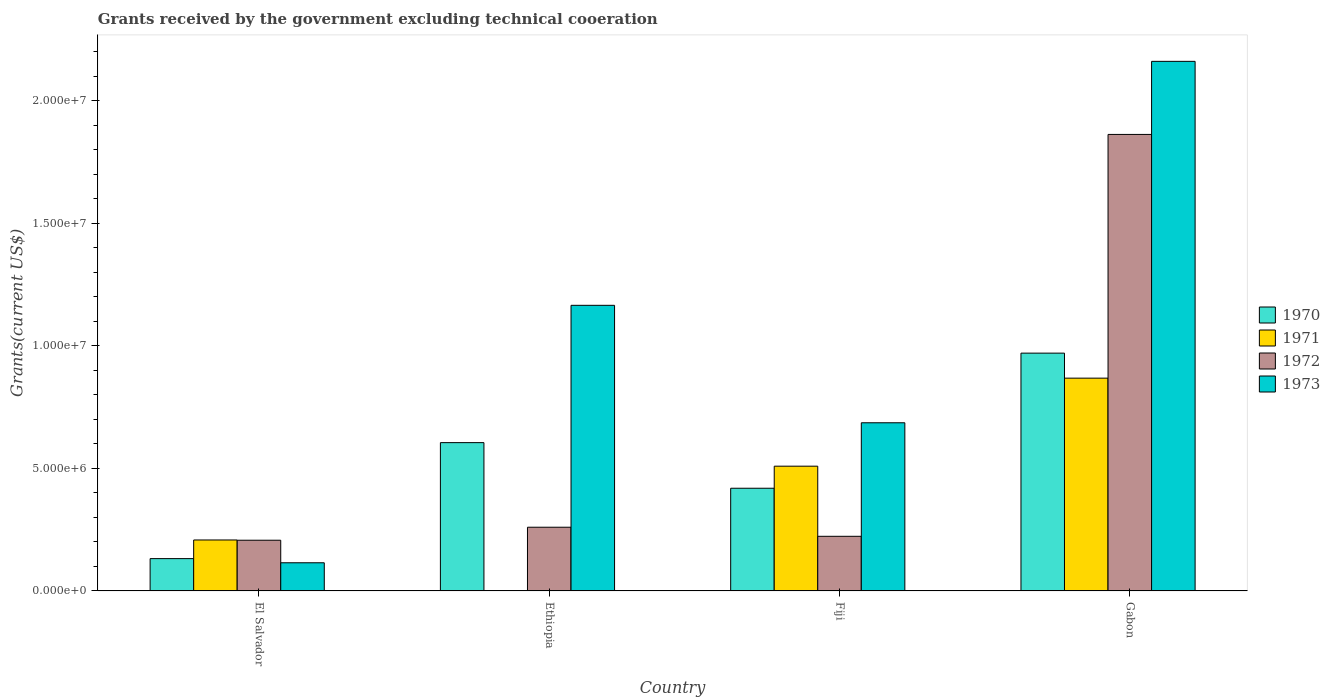How many different coloured bars are there?
Your answer should be very brief. 4. Are the number of bars per tick equal to the number of legend labels?
Offer a terse response. No. How many bars are there on the 1st tick from the left?
Keep it short and to the point. 4. What is the label of the 1st group of bars from the left?
Your answer should be very brief. El Salvador. In how many cases, is the number of bars for a given country not equal to the number of legend labels?
Your answer should be compact. 1. What is the total grants received by the government in 1970 in Fiji?
Keep it short and to the point. 4.19e+06. Across all countries, what is the maximum total grants received by the government in 1970?
Provide a succinct answer. 9.70e+06. Across all countries, what is the minimum total grants received by the government in 1970?
Your answer should be compact. 1.32e+06. In which country was the total grants received by the government in 1971 maximum?
Give a very brief answer. Gabon. What is the total total grants received by the government in 1973 in the graph?
Ensure brevity in your answer.  4.13e+07. What is the difference between the total grants received by the government in 1972 in Ethiopia and that in Gabon?
Make the answer very short. -1.60e+07. What is the difference between the total grants received by the government in 1970 in El Salvador and the total grants received by the government in 1972 in Gabon?
Your response must be concise. -1.73e+07. What is the average total grants received by the government in 1972 per country?
Offer a very short reply. 6.38e+06. What is the difference between the total grants received by the government of/in 1972 and total grants received by the government of/in 1970 in Gabon?
Provide a short and direct response. 8.92e+06. What is the ratio of the total grants received by the government in 1970 in El Salvador to that in Gabon?
Provide a succinct answer. 0.14. Is the total grants received by the government in 1970 in El Salvador less than that in Ethiopia?
Your answer should be compact. Yes. What is the difference between the highest and the second highest total grants received by the government in 1972?
Ensure brevity in your answer.  1.64e+07. What is the difference between the highest and the lowest total grants received by the government in 1971?
Make the answer very short. 8.68e+06. In how many countries, is the total grants received by the government in 1970 greater than the average total grants received by the government in 1970 taken over all countries?
Your response must be concise. 2. Is it the case that in every country, the sum of the total grants received by the government in 1970 and total grants received by the government in 1971 is greater than the sum of total grants received by the government in 1972 and total grants received by the government in 1973?
Provide a succinct answer. No. Is it the case that in every country, the sum of the total grants received by the government in 1971 and total grants received by the government in 1970 is greater than the total grants received by the government in 1973?
Offer a terse response. No. How many bars are there?
Make the answer very short. 15. How many countries are there in the graph?
Your answer should be very brief. 4. How many legend labels are there?
Your response must be concise. 4. What is the title of the graph?
Make the answer very short. Grants received by the government excluding technical cooeration. What is the label or title of the X-axis?
Offer a terse response. Country. What is the label or title of the Y-axis?
Provide a short and direct response. Grants(current US$). What is the Grants(current US$) in 1970 in El Salvador?
Offer a terse response. 1.32e+06. What is the Grants(current US$) of 1971 in El Salvador?
Your answer should be very brief. 2.08e+06. What is the Grants(current US$) of 1972 in El Salvador?
Give a very brief answer. 2.07e+06. What is the Grants(current US$) in 1973 in El Salvador?
Your response must be concise. 1.15e+06. What is the Grants(current US$) in 1970 in Ethiopia?
Provide a short and direct response. 6.05e+06. What is the Grants(current US$) of 1972 in Ethiopia?
Offer a very short reply. 2.60e+06. What is the Grants(current US$) in 1973 in Ethiopia?
Offer a very short reply. 1.16e+07. What is the Grants(current US$) in 1970 in Fiji?
Your answer should be compact. 4.19e+06. What is the Grants(current US$) of 1971 in Fiji?
Offer a very short reply. 5.09e+06. What is the Grants(current US$) of 1972 in Fiji?
Your answer should be very brief. 2.23e+06. What is the Grants(current US$) of 1973 in Fiji?
Offer a terse response. 6.86e+06. What is the Grants(current US$) in 1970 in Gabon?
Your response must be concise. 9.70e+06. What is the Grants(current US$) of 1971 in Gabon?
Offer a terse response. 8.68e+06. What is the Grants(current US$) in 1972 in Gabon?
Your answer should be very brief. 1.86e+07. What is the Grants(current US$) in 1973 in Gabon?
Ensure brevity in your answer.  2.16e+07. Across all countries, what is the maximum Grants(current US$) in 1970?
Your response must be concise. 9.70e+06. Across all countries, what is the maximum Grants(current US$) in 1971?
Ensure brevity in your answer.  8.68e+06. Across all countries, what is the maximum Grants(current US$) of 1972?
Your response must be concise. 1.86e+07. Across all countries, what is the maximum Grants(current US$) of 1973?
Make the answer very short. 2.16e+07. Across all countries, what is the minimum Grants(current US$) in 1970?
Ensure brevity in your answer.  1.32e+06. Across all countries, what is the minimum Grants(current US$) of 1972?
Make the answer very short. 2.07e+06. Across all countries, what is the minimum Grants(current US$) of 1973?
Make the answer very short. 1.15e+06. What is the total Grants(current US$) in 1970 in the graph?
Make the answer very short. 2.13e+07. What is the total Grants(current US$) of 1971 in the graph?
Give a very brief answer. 1.58e+07. What is the total Grants(current US$) of 1972 in the graph?
Ensure brevity in your answer.  2.55e+07. What is the total Grants(current US$) of 1973 in the graph?
Your answer should be very brief. 4.13e+07. What is the difference between the Grants(current US$) in 1970 in El Salvador and that in Ethiopia?
Your answer should be compact. -4.73e+06. What is the difference between the Grants(current US$) of 1972 in El Salvador and that in Ethiopia?
Give a very brief answer. -5.30e+05. What is the difference between the Grants(current US$) of 1973 in El Salvador and that in Ethiopia?
Keep it short and to the point. -1.05e+07. What is the difference between the Grants(current US$) of 1970 in El Salvador and that in Fiji?
Your response must be concise. -2.87e+06. What is the difference between the Grants(current US$) of 1971 in El Salvador and that in Fiji?
Keep it short and to the point. -3.01e+06. What is the difference between the Grants(current US$) of 1972 in El Salvador and that in Fiji?
Give a very brief answer. -1.60e+05. What is the difference between the Grants(current US$) of 1973 in El Salvador and that in Fiji?
Make the answer very short. -5.71e+06. What is the difference between the Grants(current US$) in 1970 in El Salvador and that in Gabon?
Your answer should be very brief. -8.38e+06. What is the difference between the Grants(current US$) of 1971 in El Salvador and that in Gabon?
Offer a terse response. -6.60e+06. What is the difference between the Grants(current US$) in 1972 in El Salvador and that in Gabon?
Offer a terse response. -1.66e+07. What is the difference between the Grants(current US$) of 1973 in El Salvador and that in Gabon?
Provide a short and direct response. -2.04e+07. What is the difference between the Grants(current US$) of 1970 in Ethiopia and that in Fiji?
Give a very brief answer. 1.86e+06. What is the difference between the Grants(current US$) of 1972 in Ethiopia and that in Fiji?
Ensure brevity in your answer.  3.70e+05. What is the difference between the Grants(current US$) of 1973 in Ethiopia and that in Fiji?
Your answer should be very brief. 4.79e+06. What is the difference between the Grants(current US$) in 1970 in Ethiopia and that in Gabon?
Keep it short and to the point. -3.65e+06. What is the difference between the Grants(current US$) in 1972 in Ethiopia and that in Gabon?
Your response must be concise. -1.60e+07. What is the difference between the Grants(current US$) of 1973 in Ethiopia and that in Gabon?
Ensure brevity in your answer.  -9.95e+06. What is the difference between the Grants(current US$) of 1970 in Fiji and that in Gabon?
Offer a very short reply. -5.51e+06. What is the difference between the Grants(current US$) in 1971 in Fiji and that in Gabon?
Your answer should be compact. -3.59e+06. What is the difference between the Grants(current US$) of 1972 in Fiji and that in Gabon?
Provide a succinct answer. -1.64e+07. What is the difference between the Grants(current US$) of 1973 in Fiji and that in Gabon?
Offer a very short reply. -1.47e+07. What is the difference between the Grants(current US$) of 1970 in El Salvador and the Grants(current US$) of 1972 in Ethiopia?
Ensure brevity in your answer.  -1.28e+06. What is the difference between the Grants(current US$) of 1970 in El Salvador and the Grants(current US$) of 1973 in Ethiopia?
Provide a succinct answer. -1.03e+07. What is the difference between the Grants(current US$) of 1971 in El Salvador and the Grants(current US$) of 1972 in Ethiopia?
Make the answer very short. -5.20e+05. What is the difference between the Grants(current US$) in 1971 in El Salvador and the Grants(current US$) in 1973 in Ethiopia?
Your answer should be compact. -9.57e+06. What is the difference between the Grants(current US$) in 1972 in El Salvador and the Grants(current US$) in 1973 in Ethiopia?
Keep it short and to the point. -9.58e+06. What is the difference between the Grants(current US$) in 1970 in El Salvador and the Grants(current US$) in 1971 in Fiji?
Ensure brevity in your answer.  -3.77e+06. What is the difference between the Grants(current US$) of 1970 in El Salvador and the Grants(current US$) of 1972 in Fiji?
Offer a terse response. -9.10e+05. What is the difference between the Grants(current US$) in 1970 in El Salvador and the Grants(current US$) in 1973 in Fiji?
Provide a succinct answer. -5.54e+06. What is the difference between the Grants(current US$) of 1971 in El Salvador and the Grants(current US$) of 1972 in Fiji?
Keep it short and to the point. -1.50e+05. What is the difference between the Grants(current US$) of 1971 in El Salvador and the Grants(current US$) of 1973 in Fiji?
Offer a terse response. -4.78e+06. What is the difference between the Grants(current US$) in 1972 in El Salvador and the Grants(current US$) in 1973 in Fiji?
Ensure brevity in your answer.  -4.79e+06. What is the difference between the Grants(current US$) in 1970 in El Salvador and the Grants(current US$) in 1971 in Gabon?
Keep it short and to the point. -7.36e+06. What is the difference between the Grants(current US$) of 1970 in El Salvador and the Grants(current US$) of 1972 in Gabon?
Your answer should be compact. -1.73e+07. What is the difference between the Grants(current US$) in 1970 in El Salvador and the Grants(current US$) in 1973 in Gabon?
Make the answer very short. -2.03e+07. What is the difference between the Grants(current US$) of 1971 in El Salvador and the Grants(current US$) of 1972 in Gabon?
Your answer should be very brief. -1.65e+07. What is the difference between the Grants(current US$) of 1971 in El Salvador and the Grants(current US$) of 1973 in Gabon?
Provide a short and direct response. -1.95e+07. What is the difference between the Grants(current US$) in 1972 in El Salvador and the Grants(current US$) in 1973 in Gabon?
Your answer should be very brief. -1.95e+07. What is the difference between the Grants(current US$) of 1970 in Ethiopia and the Grants(current US$) of 1971 in Fiji?
Ensure brevity in your answer.  9.60e+05. What is the difference between the Grants(current US$) in 1970 in Ethiopia and the Grants(current US$) in 1972 in Fiji?
Offer a terse response. 3.82e+06. What is the difference between the Grants(current US$) in 1970 in Ethiopia and the Grants(current US$) in 1973 in Fiji?
Your response must be concise. -8.10e+05. What is the difference between the Grants(current US$) in 1972 in Ethiopia and the Grants(current US$) in 1973 in Fiji?
Give a very brief answer. -4.26e+06. What is the difference between the Grants(current US$) in 1970 in Ethiopia and the Grants(current US$) in 1971 in Gabon?
Offer a very short reply. -2.63e+06. What is the difference between the Grants(current US$) of 1970 in Ethiopia and the Grants(current US$) of 1972 in Gabon?
Provide a short and direct response. -1.26e+07. What is the difference between the Grants(current US$) in 1970 in Ethiopia and the Grants(current US$) in 1973 in Gabon?
Offer a terse response. -1.56e+07. What is the difference between the Grants(current US$) in 1972 in Ethiopia and the Grants(current US$) in 1973 in Gabon?
Your response must be concise. -1.90e+07. What is the difference between the Grants(current US$) of 1970 in Fiji and the Grants(current US$) of 1971 in Gabon?
Make the answer very short. -4.49e+06. What is the difference between the Grants(current US$) of 1970 in Fiji and the Grants(current US$) of 1972 in Gabon?
Provide a succinct answer. -1.44e+07. What is the difference between the Grants(current US$) of 1970 in Fiji and the Grants(current US$) of 1973 in Gabon?
Ensure brevity in your answer.  -1.74e+07. What is the difference between the Grants(current US$) in 1971 in Fiji and the Grants(current US$) in 1972 in Gabon?
Your answer should be compact. -1.35e+07. What is the difference between the Grants(current US$) of 1971 in Fiji and the Grants(current US$) of 1973 in Gabon?
Provide a short and direct response. -1.65e+07. What is the difference between the Grants(current US$) of 1972 in Fiji and the Grants(current US$) of 1973 in Gabon?
Provide a short and direct response. -1.94e+07. What is the average Grants(current US$) of 1970 per country?
Make the answer very short. 5.32e+06. What is the average Grants(current US$) of 1971 per country?
Your response must be concise. 3.96e+06. What is the average Grants(current US$) of 1972 per country?
Ensure brevity in your answer.  6.38e+06. What is the average Grants(current US$) of 1973 per country?
Ensure brevity in your answer.  1.03e+07. What is the difference between the Grants(current US$) in 1970 and Grants(current US$) in 1971 in El Salvador?
Your answer should be compact. -7.60e+05. What is the difference between the Grants(current US$) in 1970 and Grants(current US$) in 1972 in El Salvador?
Provide a short and direct response. -7.50e+05. What is the difference between the Grants(current US$) of 1970 and Grants(current US$) of 1973 in El Salvador?
Give a very brief answer. 1.70e+05. What is the difference between the Grants(current US$) in 1971 and Grants(current US$) in 1973 in El Salvador?
Your answer should be compact. 9.30e+05. What is the difference between the Grants(current US$) in 1972 and Grants(current US$) in 1973 in El Salvador?
Your answer should be compact. 9.20e+05. What is the difference between the Grants(current US$) in 1970 and Grants(current US$) in 1972 in Ethiopia?
Offer a very short reply. 3.45e+06. What is the difference between the Grants(current US$) in 1970 and Grants(current US$) in 1973 in Ethiopia?
Keep it short and to the point. -5.60e+06. What is the difference between the Grants(current US$) in 1972 and Grants(current US$) in 1973 in Ethiopia?
Ensure brevity in your answer.  -9.05e+06. What is the difference between the Grants(current US$) of 1970 and Grants(current US$) of 1971 in Fiji?
Make the answer very short. -9.00e+05. What is the difference between the Grants(current US$) in 1970 and Grants(current US$) in 1972 in Fiji?
Provide a short and direct response. 1.96e+06. What is the difference between the Grants(current US$) of 1970 and Grants(current US$) of 1973 in Fiji?
Offer a terse response. -2.67e+06. What is the difference between the Grants(current US$) of 1971 and Grants(current US$) of 1972 in Fiji?
Your answer should be very brief. 2.86e+06. What is the difference between the Grants(current US$) in 1971 and Grants(current US$) in 1973 in Fiji?
Your response must be concise. -1.77e+06. What is the difference between the Grants(current US$) of 1972 and Grants(current US$) of 1973 in Fiji?
Provide a short and direct response. -4.63e+06. What is the difference between the Grants(current US$) in 1970 and Grants(current US$) in 1971 in Gabon?
Make the answer very short. 1.02e+06. What is the difference between the Grants(current US$) of 1970 and Grants(current US$) of 1972 in Gabon?
Offer a terse response. -8.92e+06. What is the difference between the Grants(current US$) in 1970 and Grants(current US$) in 1973 in Gabon?
Your response must be concise. -1.19e+07. What is the difference between the Grants(current US$) of 1971 and Grants(current US$) of 1972 in Gabon?
Your answer should be compact. -9.94e+06. What is the difference between the Grants(current US$) of 1971 and Grants(current US$) of 1973 in Gabon?
Your answer should be very brief. -1.29e+07. What is the difference between the Grants(current US$) in 1972 and Grants(current US$) in 1973 in Gabon?
Your response must be concise. -2.98e+06. What is the ratio of the Grants(current US$) of 1970 in El Salvador to that in Ethiopia?
Your response must be concise. 0.22. What is the ratio of the Grants(current US$) in 1972 in El Salvador to that in Ethiopia?
Your answer should be compact. 0.8. What is the ratio of the Grants(current US$) of 1973 in El Salvador to that in Ethiopia?
Provide a short and direct response. 0.1. What is the ratio of the Grants(current US$) in 1970 in El Salvador to that in Fiji?
Make the answer very short. 0.32. What is the ratio of the Grants(current US$) of 1971 in El Salvador to that in Fiji?
Keep it short and to the point. 0.41. What is the ratio of the Grants(current US$) in 1972 in El Salvador to that in Fiji?
Give a very brief answer. 0.93. What is the ratio of the Grants(current US$) of 1973 in El Salvador to that in Fiji?
Make the answer very short. 0.17. What is the ratio of the Grants(current US$) of 1970 in El Salvador to that in Gabon?
Make the answer very short. 0.14. What is the ratio of the Grants(current US$) in 1971 in El Salvador to that in Gabon?
Your answer should be compact. 0.24. What is the ratio of the Grants(current US$) in 1972 in El Salvador to that in Gabon?
Offer a terse response. 0.11. What is the ratio of the Grants(current US$) in 1973 in El Salvador to that in Gabon?
Provide a succinct answer. 0.05. What is the ratio of the Grants(current US$) of 1970 in Ethiopia to that in Fiji?
Your answer should be very brief. 1.44. What is the ratio of the Grants(current US$) of 1972 in Ethiopia to that in Fiji?
Give a very brief answer. 1.17. What is the ratio of the Grants(current US$) in 1973 in Ethiopia to that in Fiji?
Your answer should be compact. 1.7. What is the ratio of the Grants(current US$) in 1970 in Ethiopia to that in Gabon?
Keep it short and to the point. 0.62. What is the ratio of the Grants(current US$) of 1972 in Ethiopia to that in Gabon?
Your answer should be compact. 0.14. What is the ratio of the Grants(current US$) in 1973 in Ethiopia to that in Gabon?
Provide a short and direct response. 0.54. What is the ratio of the Grants(current US$) of 1970 in Fiji to that in Gabon?
Your answer should be compact. 0.43. What is the ratio of the Grants(current US$) in 1971 in Fiji to that in Gabon?
Give a very brief answer. 0.59. What is the ratio of the Grants(current US$) in 1972 in Fiji to that in Gabon?
Give a very brief answer. 0.12. What is the ratio of the Grants(current US$) in 1973 in Fiji to that in Gabon?
Make the answer very short. 0.32. What is the difference between the highest and the second highest Grants(current US$) of 1970?
Ensure brevity in your answer.  3.65e+06. What is the difference between the highest and the second highest Grants(current US$) of 1971?
Offer a terse response. 3.59e+06. What is the difference between the highest and the second highest Grants(current US$) of 1972?
Offer a terse response. 1.60e+07. What is the difference between the highest and the second highest Grants(current US$) of 1973?
Give a very brief answer. 9.95e+06. What is the difference between the highest and the lowest Grants(current US$) of 1970?
Make the answer very short. 8.38e+06. What is the difference between the highest and the lowest Grants(current US$) of 1971?
Keep it short and to the point. 8.68e+06. What is the difference between the highest and the lowest Grants(current US$) in 1972?
Provide a short and direct response. 1.66e+07. What is the difference between the highest and the lowest Grants(current US$) in 1973?
Ensure brevity in your answer.  2.04e+07. 